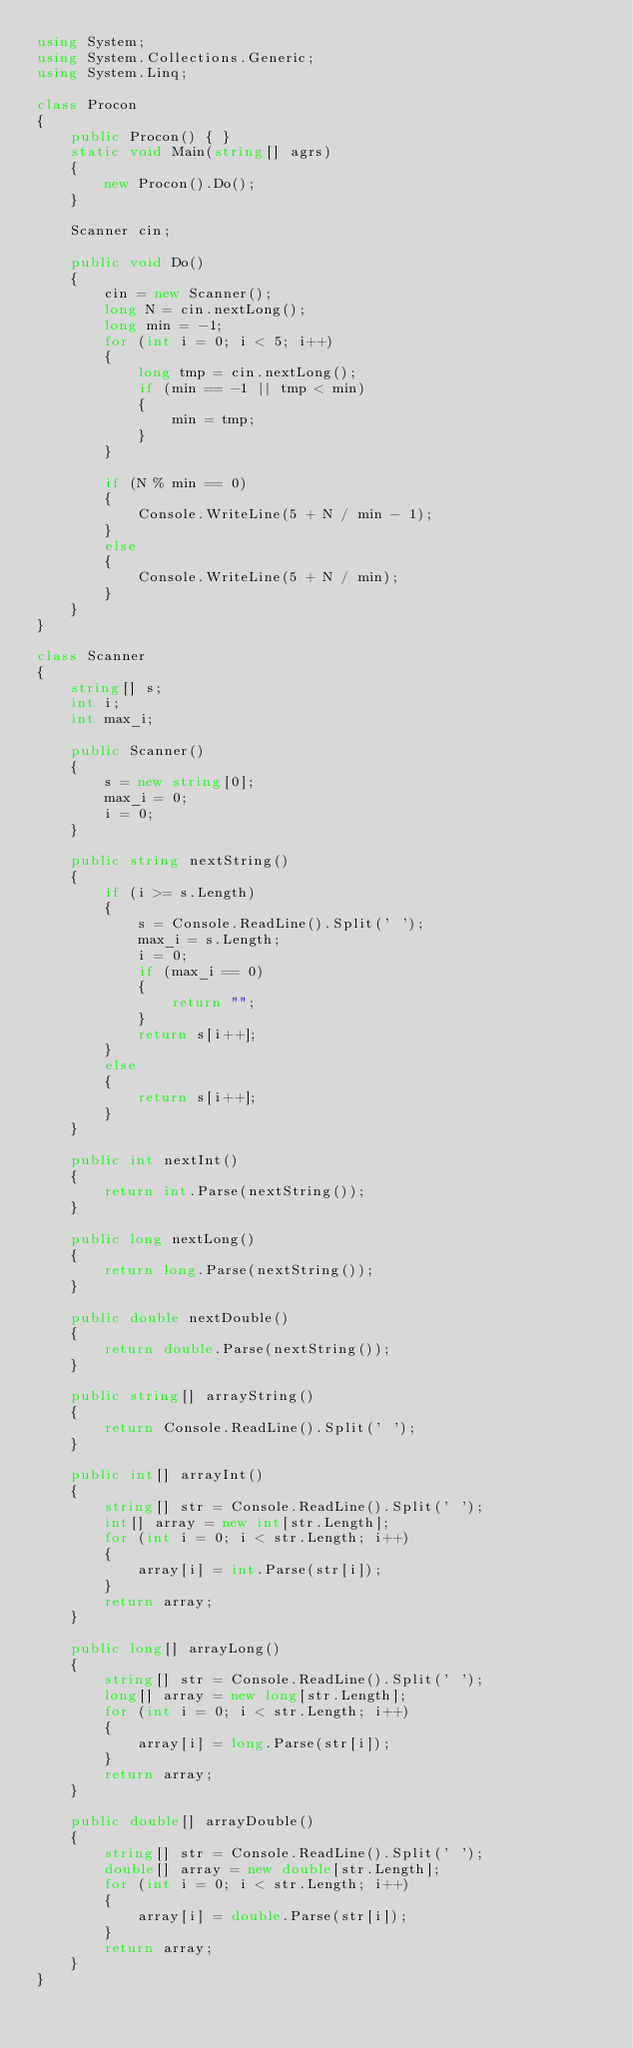<code> <loc_0><loc_0><loc_500><loc_500><_C#_>using System;
using System.Collections.Generic;
using System.Linq;

class Procon
{
    public Procon() { }
    static void Main(string[] agrs)
    {
        new Procon().Do();
    }

    Scanner cin;

    public void Do()
    {
        cin = new Scanner();
        long N = cin.nextLong();
        long min = -1;
        for (int i = 0; i < 5; i++)
        {
            long tmp = cin.nextLong();
            if (min == -1 || tmp < min)
            {
                min = tmp;
            }
        }

        if (N % min == 0)
        {
            Console.WriteLine(5 + N / min - 1);
        }
        else
        {
            Console.WriteLine(5 + N / min);
        }
    }
}

class Scanner
{
    string[] s;
    int i;
    int max_i;

    public Scanner()
    {
        s = new string[0];
        max_i = 0;
        i = 0;
    }

    public string nextString()
    {
        if (i >= s.Length)
        {
            s = Console.ReadLine().Split(' ');
            max_i = s.Length;
            i = 0;
            if (max_i == 0)
            {
                return "";
            }
            return s[i++];
        }
        else
        {
            return s[i++];
        }
    }

    public int nextInt()
    {
        return int.Parse(nextString());
    }

    public long nextLong()
    {
        return long.Parse(nextString());
    }

    public double nextDouble()
    {
        return double.Parse(nextString());
    }

    public string[] arrayString()
    {
        return Console.ReadLine().Split(' ');
    }

    public int[] arrayInt()
    {
        string[] str = Console.ReadLine().Split(' ');
        int[] array = new int[str.Length];
        for (int i = 0; i < str.Length; i++)
        {
            array[i] = int.Parse(str[i]);
        }
        return array;
    }

    public long[] arrayLong()
    {
        string[] str = Console.ReadLine().Split(' ');
        long[] array = new long[str.Length];
        for (int i = 0; i < str.Length; i++)
        {
            array[i] = long.Parse(str[i]);
        }
        return array;
    }

    public double[] arrayDouble()
    {
        string[] str = Console.ReadLine().Split(' ');
        double[] array = new double[str.Length];
        for (int i = 0; i < str.Length; i++)
        {
            array[i] = double.Parse(str[i]);
        }
        return array;
    }
}</code> 